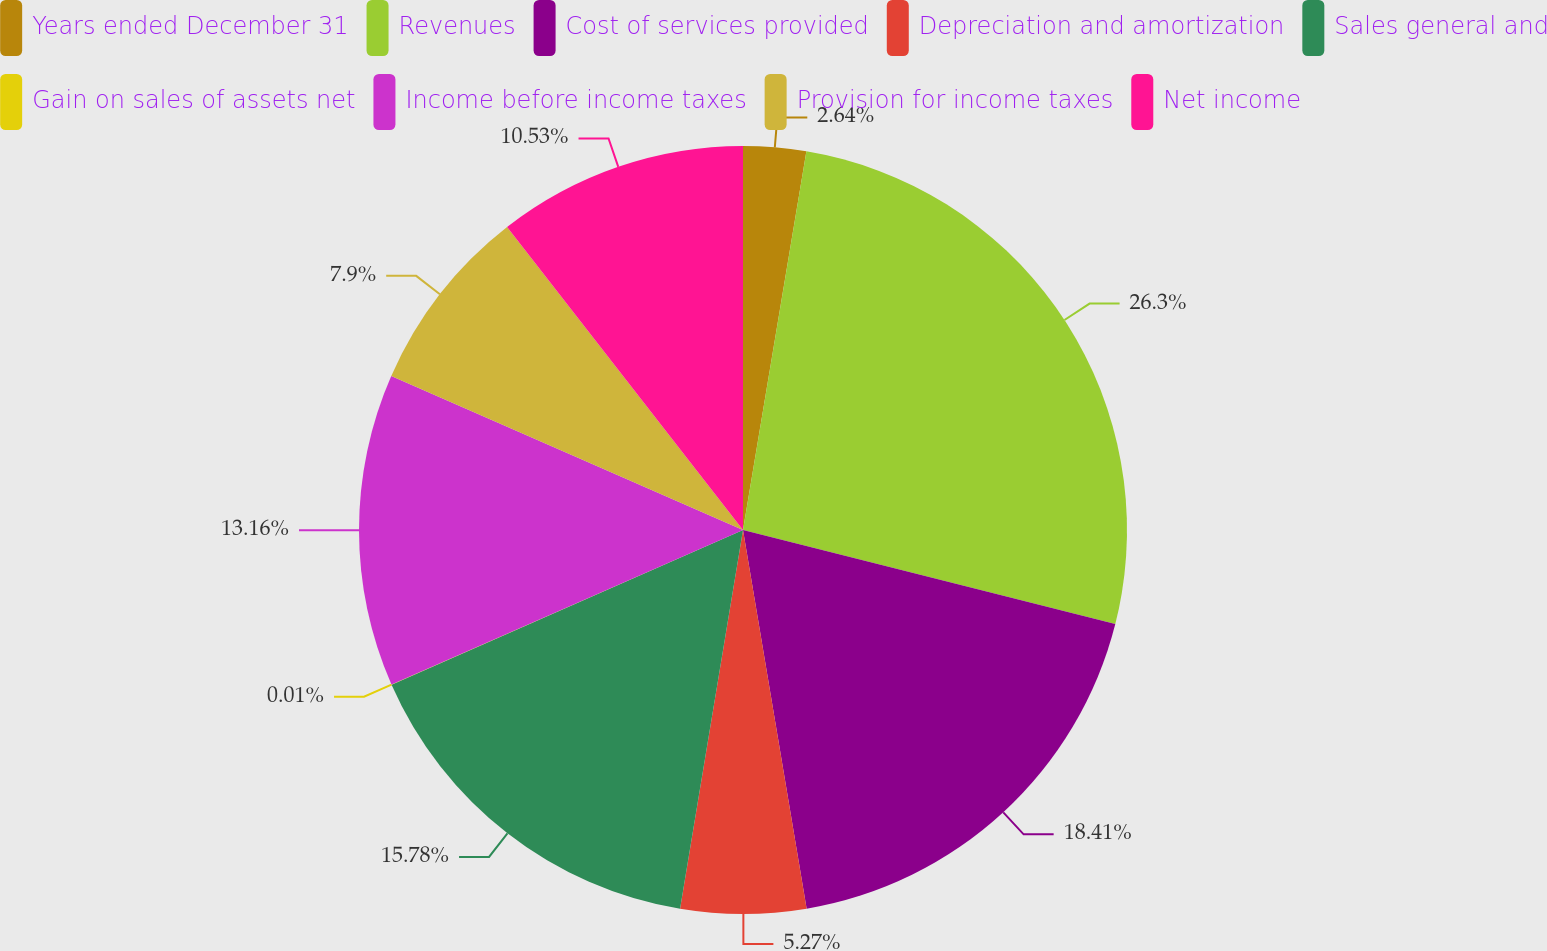<chart> <loc_0><loc_0><loc_500><loc_500><pie_chart><fcel>Years ended December 31<fcel>Revenues<fcel>Cost of services provided<fcel>Depreciation and amortization<fcel>Sales general and<fcel>Gain on sales of assets net<fcel>Income before income taxes<fcel>Provision for income taxes<fcel>Net income<nl><fcel>2.64%<fcel>26.3%<fcel>18.41%<fcel>5.27%<fcel>15.78%<fcel>0.01%<fcel>13.16%<fcel>7.9%<fcel>10.53%<nl></chart> 